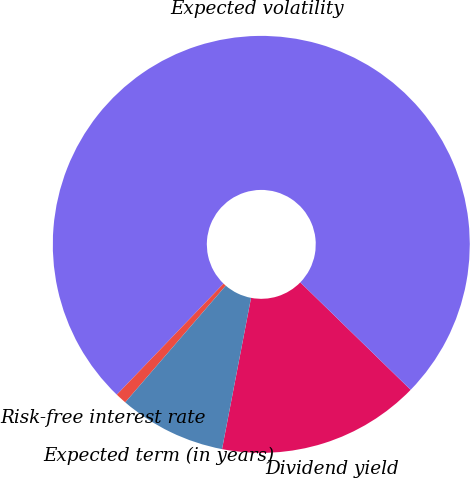Convert chart. <chart><loc_0><loc_0><loc_500><loc_500><pie_chart><fcel>Dividend yield<fcel>Expected volatility<fcel>Risk-free interest rate<fcel>Expected term (in years)<nl><fcel>15.73%<fcel>75.11%<fcel>0.87%<fcel>8.3%<nl></chart> 